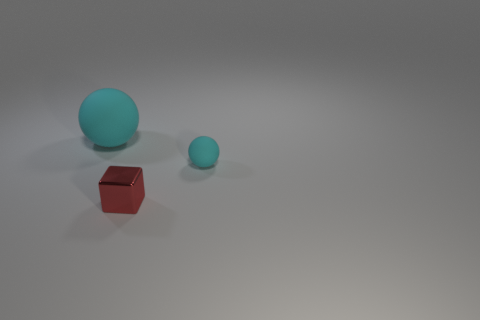Add 2 metal things. How many objects exist? 5 Subtract all spheres. How many objects are left? 1 Subtract 0 blue cylinders. How many objects are left? 3 Subtract all small cyan matte spheres. Subtract all gray things. How many objects are left? 2 Add 1 small cyan spheres. How many small cyan spheres are left? 2 Add 2 big rubber cubes. How many big rubber cubes exist? 2 